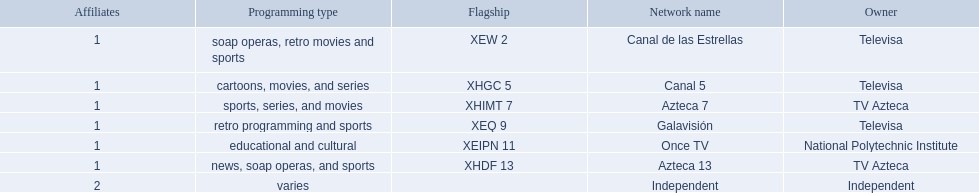What station shows cartoons? Canal 5. What station shows soap operas? Canal de las Estrellas. What station shows sports? Azteca 7. 